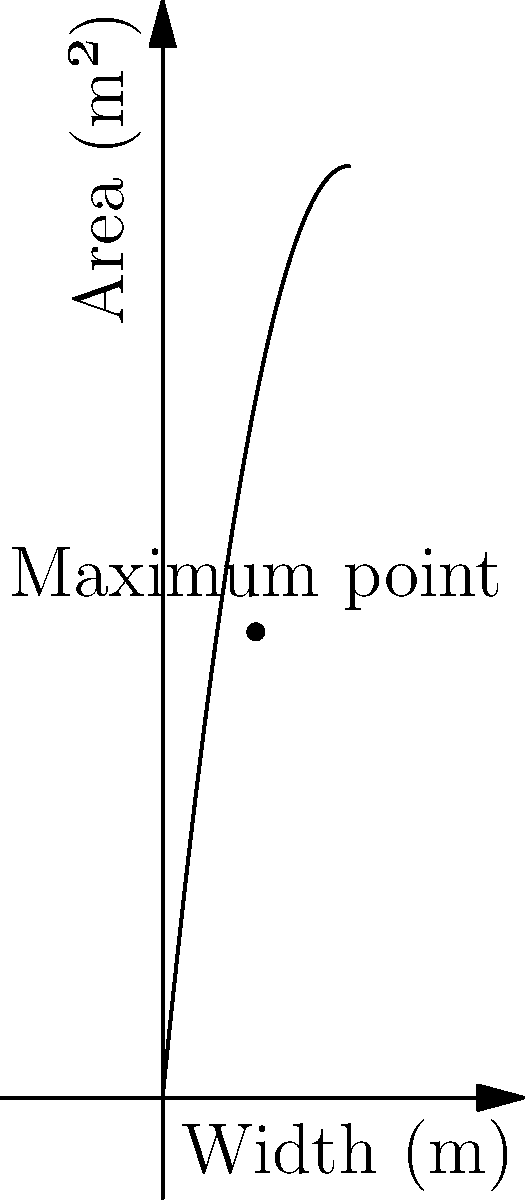As the stage manager for The Crickets' upcoming rock concert, you need to design a rectangular stage. The width of the stage can vary, but the total area is given by the function $A(x) = -x^2/4 + 10x$, where $x$ is the width in meters and $A(x)$ is the area in square meters. What width should you choose to maximize the stage area, and what is this maximum area? To find the maximum area, we need to follow these steps:

1) The function $A(x) = -x^2/4 + 10x$ is a quadratic function, which forms a parabola when graphed.

2) The maximum point of a parabola occurs at the vertex.

3) For a quadratic function in the form $f(x) = ax^2 + bx + c$, the x-coordinate of the vertex is given by $x = -b/(2a)$.

4) In our case, $a = -1/4$ and $b = 10$. So:

   $x = -10 / (2 * (-1/4)) = -10 / (-1/2) = 20$

5) To find the maximum area, we substitute this x-value back into our original function:

   $A(20) = -(20)^2/4 + 10(20) = -100 + 200 = 100$

6) Therefore, the maximum area occurs when the width is 20 meters, and the maximum area is 100 square meters.
Answer: Width: 20 m, Maximum Area: 100 m² 